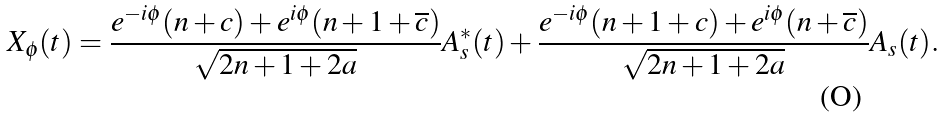<formula> <loc_0><loc_0><loc_500><loc_500>X _ { \phi } ( t ) = \frac { e ^ { - i \phi } ( n + c ) + e ^ { i \phi } ( n + 1 + \overline { c } ) } { \sqrt { 2 n + 1 + 2 a } } A _ { s } ^ { * } ( t ) + \frac { e ^ { - i \phi } ( n + 1 + c ) + e ^ { i \phi } ( n + \overline { c } ) } { \sqrt { 2 n + 1 + 2 a } } A _ { s } ( t ) .</formula> 